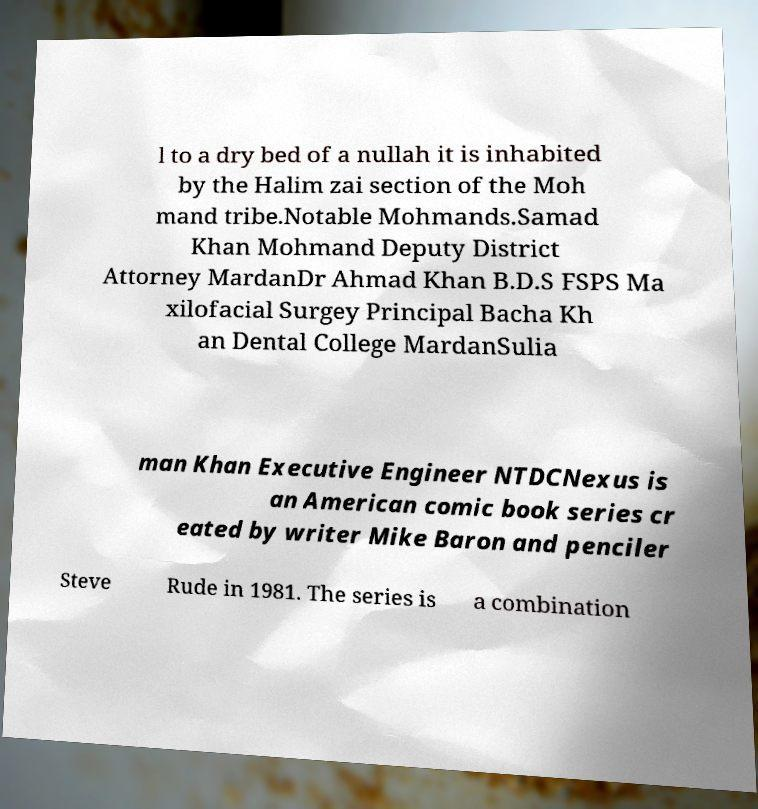I need the written content from this picture converted into text. Can you do that? l to a dry bed of a nullah it is inhabited by the Halim zai section of the Moh mand tribe.Notable Mohmands.Samad Khan Mohmand Deputy District Attorney MardanDr Ahmad Khan B.D.S FSPS Ma xilofacial Surgey Principal Bacha Kh an Dental College MardanSulia man Khan Executive Engineer NTDCNexus is an American comic book series cr eated by writer Mike Baron and penciler Steve Rude in 1981. The series is a combination 